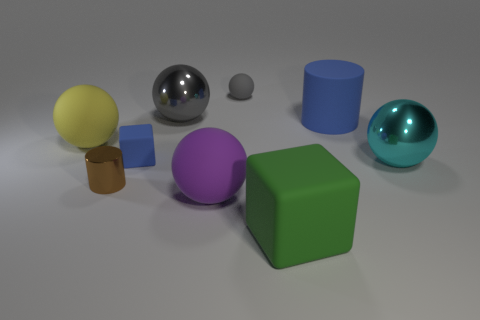Subtract all large yellow rubber spheres. How many spheres are left? 4 Add 1 tiny yellow cubes. How many objects exist? 10 Subtract all blue cylinders. How many gray spheres are left? 2 Subtract all balls. How many objects are left? 4 Subtract 4 spheres. How many spheres are left? 1 Subtract all large purple rubber things. Subtract all big yellow rubber things. How many objects are left? 7 Add 8 small blue things. How many small blue things are left? 9 Add 7 gray rubber things. How many gray rubber things exist? 8 Subtract all purple spheres. How many spheres are left? 4 Subtract 1 blue cubes. How many objects are left? 8 